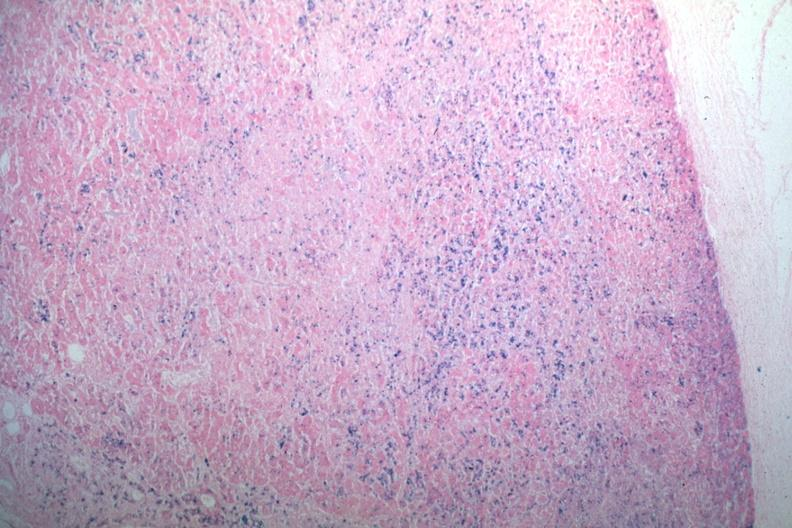what does this image show?
Answer the question using a single word or phrase. Iron stain abundant iron 